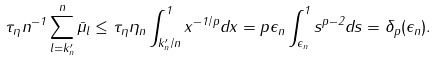<formula> <loc_0><loc_0><loc_500><loc_500>\tau _ { \eta } n ^ { - 1 } \sum _ { l = k _ { n } ^ { \prime } } ^ { n } \bar { \mu } _ { l } \leq \tau _ { \eta } \eta _ { n } \int _ { k _ { n } ^ { \prime } / n } ^ { 1 } x ^ { - 1 / p } d x = p \epsilon _ { n } \int _ { \epsilon _ { n } } ^ { 1 } s ^ { p - 2 } d s = \delta _ { p } ( \epsilon _ { n } ) .</formula> 